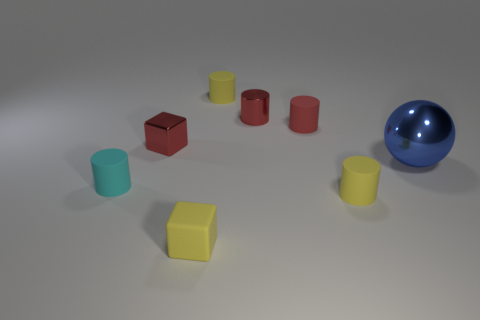Subtract all cyan cylinders. How many cylinders are left? 4 Subtract all purple cylinders. Subtract all yellow cubes. How many cylinders are left? 5 Add 1 tiny yellow things. How many objects exist? 9 Subtract all cylinders. How many objects are left? 3 Add 6 big objects. How many big objects exist? 7 Subtract 0 green spheres. How many objects are left? 8 Subtract all small brown cubes. Subtract all red metal objects. How many objects are left? 6 Add 5 red cubes. How many red cubes are left? 6 